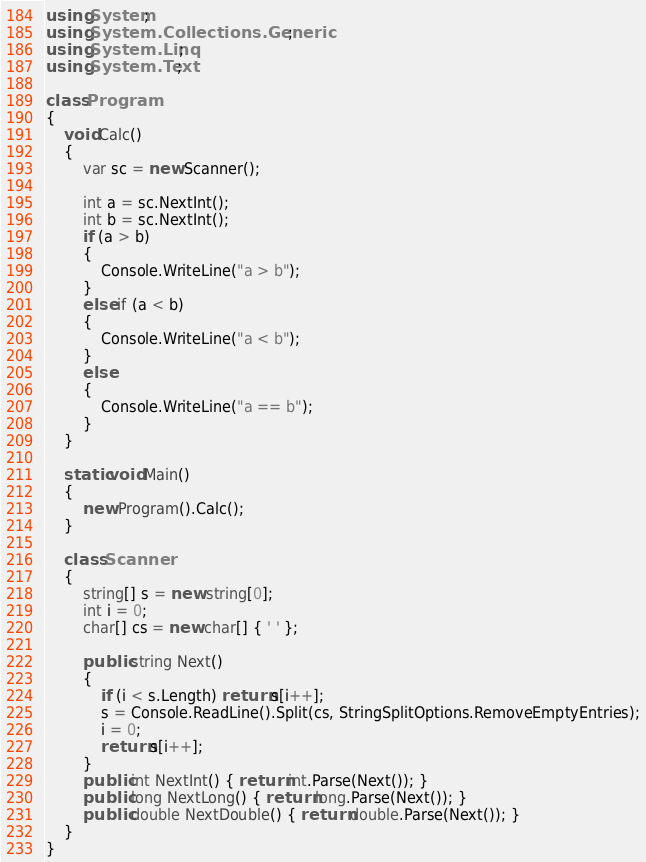Convert code to text. <code><loc_0><loc_0><loc_500><loc_500><_C#_>using System;
using System.Collections.Generic;
using System.Linq;
using System.Text;

class Program
{
    void Calc()
    {
        var sc = new Scanner();

        int a = sc.NextInt();
        int b = sc.NextInt();
        if (a > b)
        {
            Console.WriteLine("a > b");
        }
        else if (a < b)
        {
            Console.WriteLine("a < b");
        }
        else
        {
            Console.WriteLine("a == b");
        }
    }

    static void Main()
    {
        new Program().Calc();
    }

    class Scanner
    {
        string[] s = new string[0];
        int i = 0;
        char[] cs = new char[] { ' ' };

        public string Next()
        {
            if (i < s.Length) return s[i++];
            s = Console.ReadLine().Split(cs, StringSplitOptions.RemoveEmptyEntries);
            i = 0;
            return s[i++];
        }
        public int NextInt() { return int.Parse(Next()); }
        public long NextLong() { return long.Parse(Next()); }
        public double NextDouble() { return double.Parse(Next()); }
    }
}</code> 